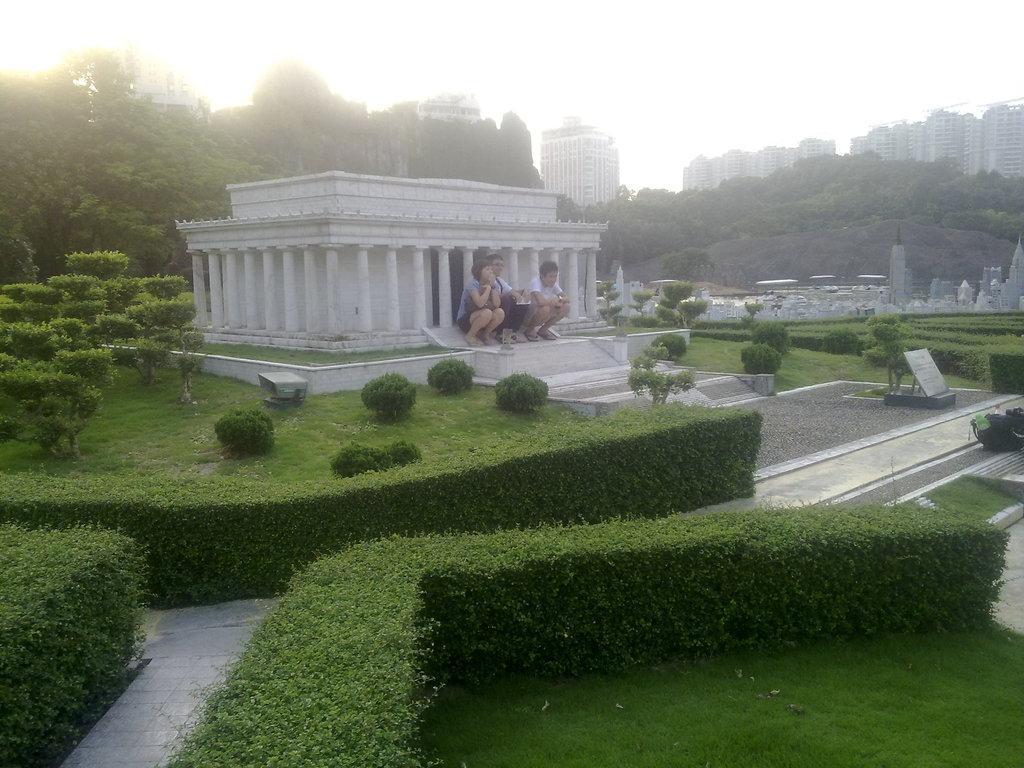Could you give a brief overview of what you see in this image? In this image I can see few building, trees, few people are sitting. In front I can see a board and green grass. The sky is in white color. 